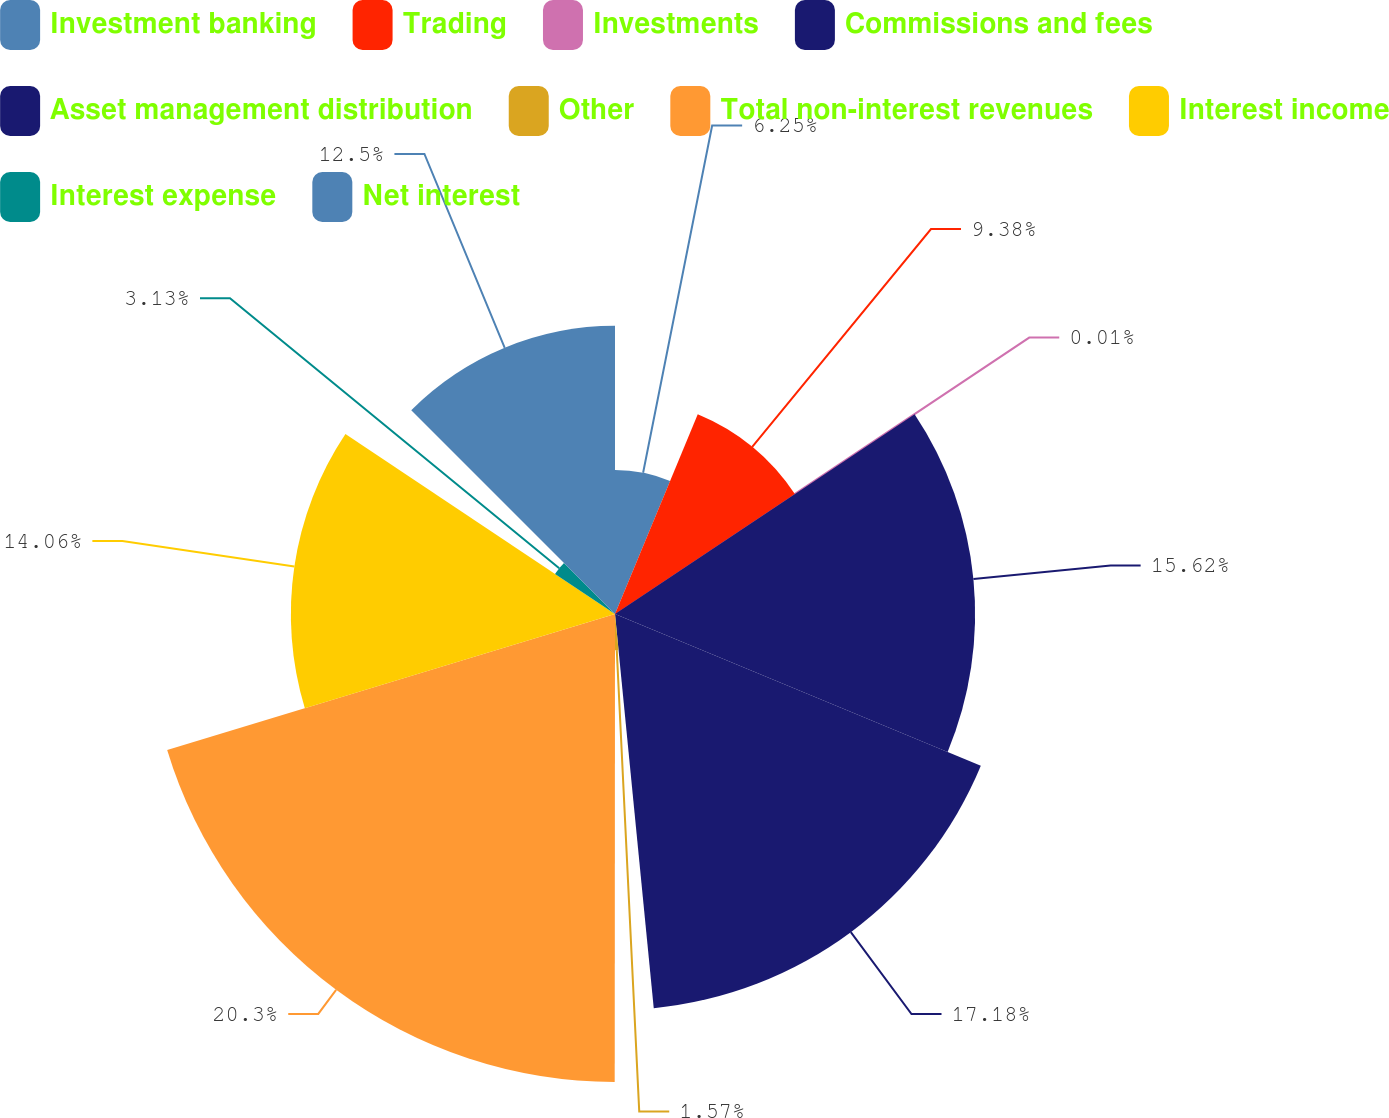Convert chart. <chart><loc_0><loc_0><loc_500><loc_500><pie_chart><fcel>Investment banking<fcel>Trading<fcel>Investments<fcel>Commissions and fees<fcel>Asset management distribution<fcel>Other<fcel>Total non-interest revenues<fcel>Interest income<fcel>Interest expense<fcel>Net interest<nl><fcel>6.25%<fcel>9.38%<fcel>0.01%<fcel>15.62%<fcel>17.18%<fcel>1.57%<fcel>20.3%<fcel>14.06%<fcel>3.13%<fcel>12.5%<nl></chart> 